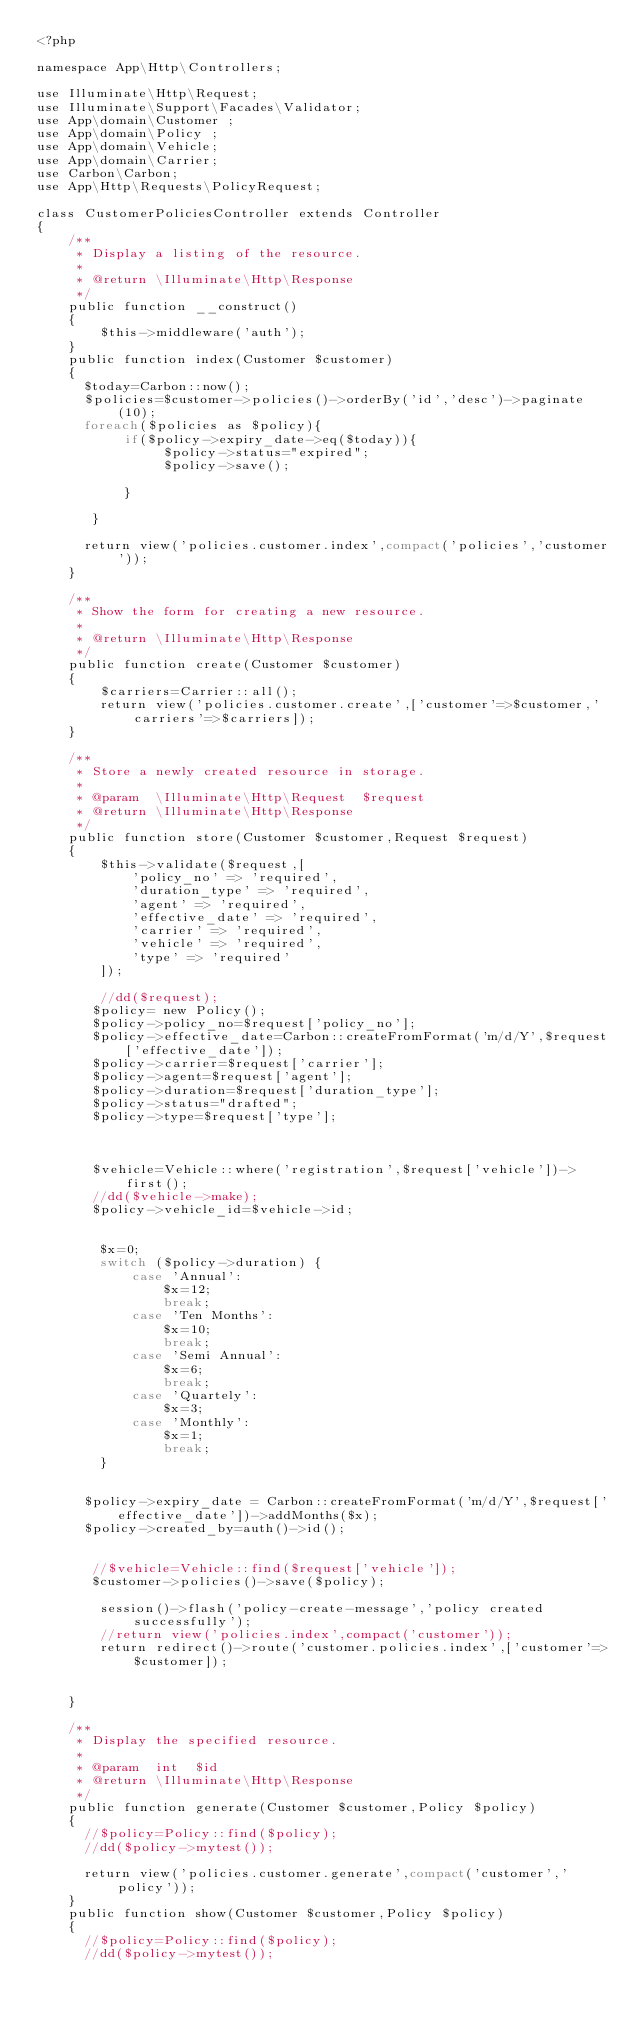Convert code to text. <code><loc_0><loc_0><loc_500><loc_500><_PHP_><?php

namespace App\Http\Controllers;

use Illuminate\Http\Request;
use Illuminate\Support\Facades\Validator;
use App\domain\Customer ;
use App\domain\Policy ;
use App\domain\Vehicle;
use App\domain\Carrier;
use Carbon\Carbon;
use App\Http\Requests\PolicyRequest;

class CustomerPoliciesController extends Controller
{
    /**
     * Display a listing of the resource.
     *
     * @return \Illuminate\Http\Response
     */
    public function __construct()
    {
        $this->middleware('auth');
    }
    public function index(Customer $customer)
    {
      $today=Carbon::now();
      $policies=$customer->policies()->orderBy('id','desc')->paginate(10);
      foreach($policies as $policy){
           if($policy->expiry_date->eq($today)){
                $policy->status="expired";
                $policy->save();

           }

       }

      return view('policies.customer.index',compact('policies','customer'));  
    }

    /**
     * Show the form for creating a new resource.
     *
     * @return \Illuminate\Http\Response
     */
    public function create(Customer $customer)
    {
        $carriers=Carrier::all();
        return view('policies.customer.create',['customer'=>$customer,'carriers'=>$carriers]);
    }

    /**
     * Store a newly created resource in storage.
     *
     * @param  \Illuminate\Http\Request  $request
     * @return \Illuminate\Http\Response
     */
    public function store(Customer $customer,Request $request)
    {  
        $this->validate($request,[
            'policy_no' => 'required',
            'duration_type' => 'required',
            'agent' => 'required',
            'effective_date' => 'required',
            'carrier' => 'required',
            'vehicle' => 'required',
            'type' => 'required'
        ]);

        //dd($request);
       $policy= new Policy();
       $policy->policy_no=$request['policy_no'];
       $policy->effective_date=Carbon::createFromFormat('m/d/Y',$request['effective_date']);
       $policy->carrier=$request['carrier'];
       $policy->agent=$request['agent'];
       $policy->duration=$request['duration_type'];
       $policy->status="drafted";
       $policy->type=$request['type'];


       
       $vehicle=Vehicle::where('registration',$request['vehicle'])->first();
       //dd($vehicle->make);
       $policy->vehicle_id=$vehicle->id;


        $x=0;
        switch ($policy->duration) {
            case 'Annual':
                $x=12;
                break;
            case 'Ten Months':
                $x=10;
                break;    
            case 'Semi Annual':
                $x=6;
                break;
            case 'Quartely':
                $x=3;
            case 'Monthly':
                $x=1;
                break;
        }


      $policy->expiry_date = Carbon::createFromFormat('m/d/Y',$request['effective_date'])->addMonths($x);
      $policy->created_by=auth()->id();


       //$vehicle=Vehicle::find($request['vehicle']);
       $customer->policies()->save($policy);

        session()->flash('policy-create-message','policy created successfully');
        //return view('policies.index',compact('customer')); 
        return redirect()->route('customer.policies.index',['customer'=>$customer]);
        
         
    }

    /**
     * Display the specified resource.
     *
     * @param  int  $id
     * @return \Illuminate\Http\Response
     */
    public function generate(Customer $customer,Policy $policy)
    {
      //$policy=Policy::find($policy);
      //dd($policy->mytest());

      return view('policies.customer.generate',compact('customer','policy'));  
    }
    public function show(Customer $customer,Policy $policy)
    {
      //$policy=Policy::find($policy);
      //dd($policy->mytest());
</code> 